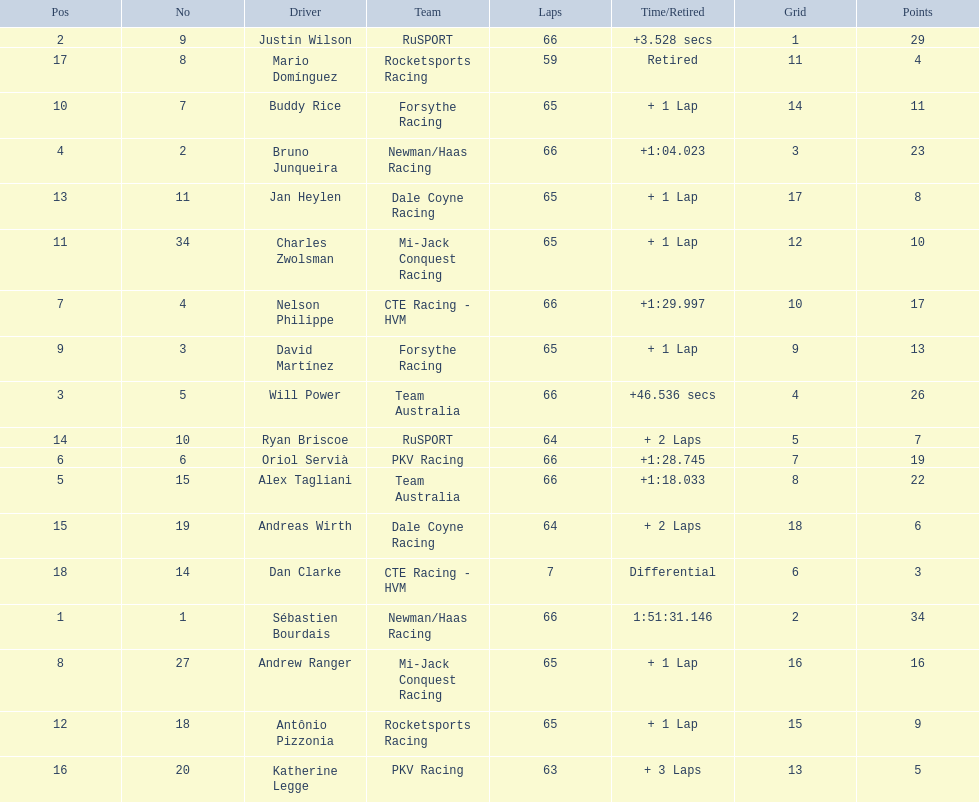How many laps did oriol servia complete at the 2006 gran premio? 66. How many laps did katherine legge complete at the 2006 gran premio? 63. Between servia and legge, who completed more laps? Oriol Servià. 